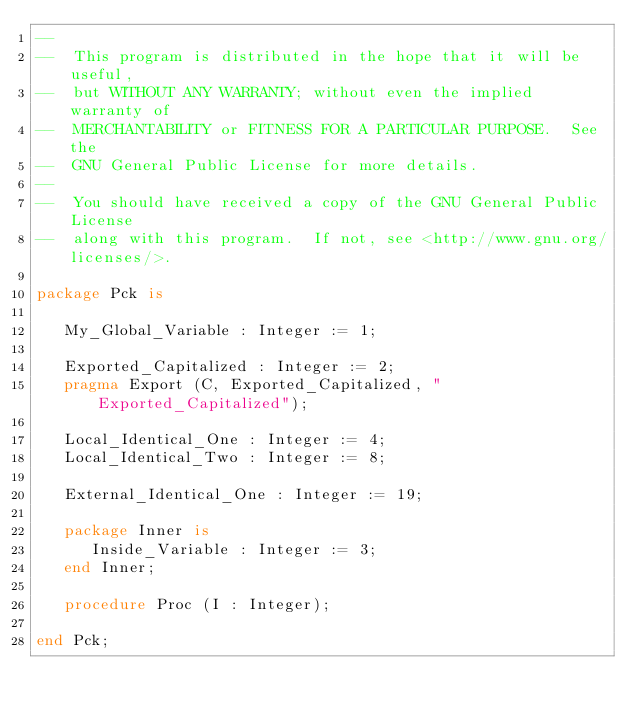Convert code to text. <code><loc_0><loc_0><loc_500><loc_500><_Ada_>--
--  This program is distributed in the hope that it will be useful,
--  but WITHOUT ANY WARRANTY; without even the implied warranty of
--  MERCHANTABILITY or FITNESS FOR A PARTICULAR PURPOSE.  See the
--  GNU General Public License for more details.
--
--  You should have received a copy of the GNU General Public License
--  along with this program.  If not, see <http://www.gnu.org/licenses/>.

package Pck is

   My_Global_Variable : Integer := 1;

   Exported_Capitalized : Integer := 2;
   pragma Export (C, Exported_Capitalized, "Exported_Capitalized");

   Local_Identical_One : Integer := 4;
   Local_Identical_Two : Integer := 8;

   External_Identical_One : Integer := 19;

   package Inner is
      Inside_Variable : Integer := 3;
   end Inner;

   procedure Proc (I : Integer);

end Pck;
</code> 